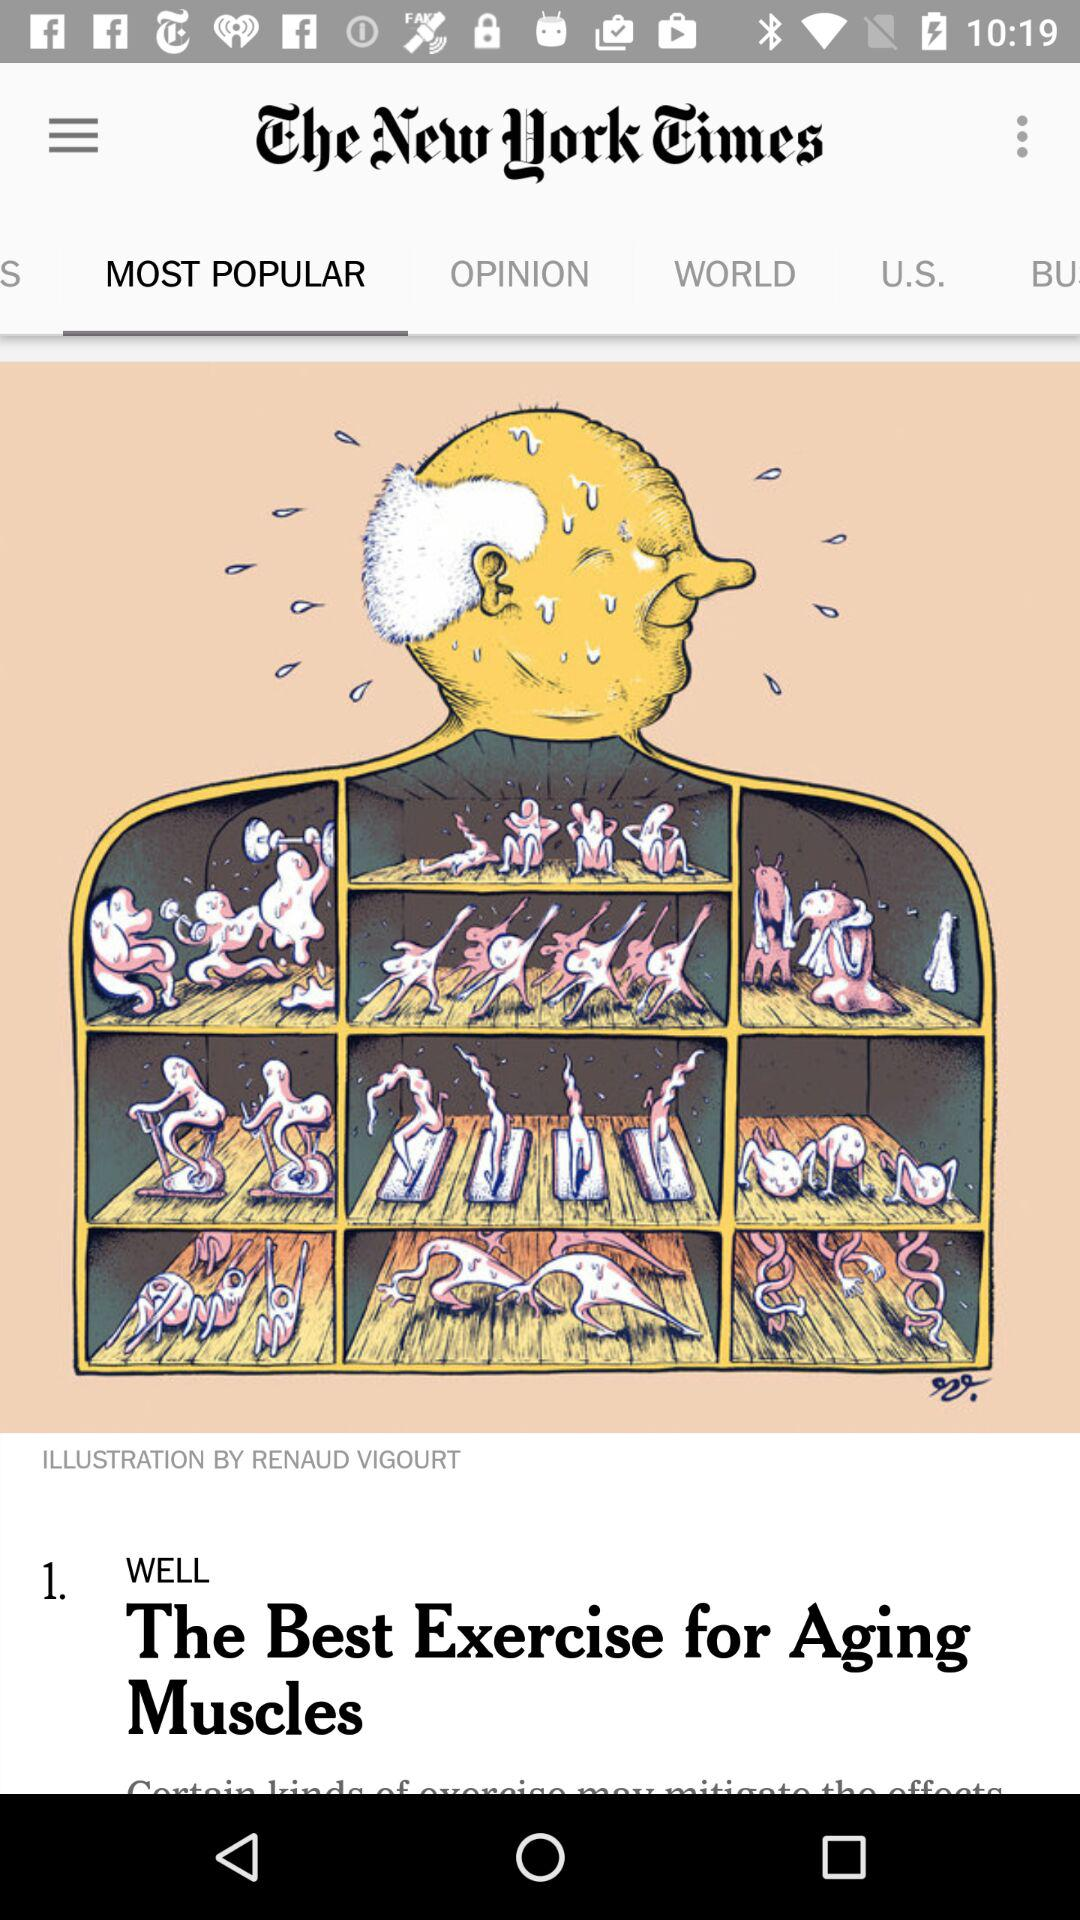What's the selected tab? The selected tab is "MOST POPULAR". 